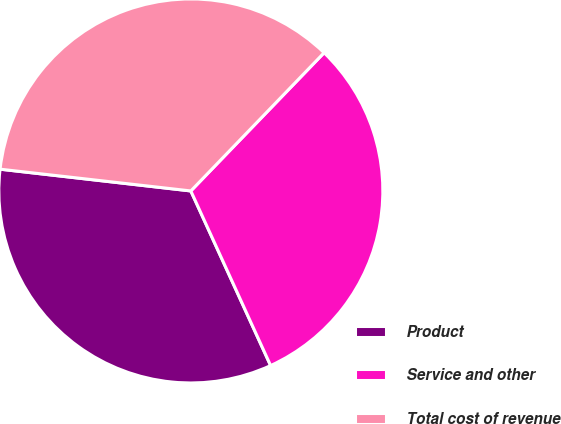Convert chart. <chart><loc_0><loc_0><loc_500><loc_500><pie_chart><fcel>Product<fcel>Service and other<fcel>Total cost of revenue<nl><fcel>33.63%<fcel>30.97%<fcel>35.4%<nl></chart> 